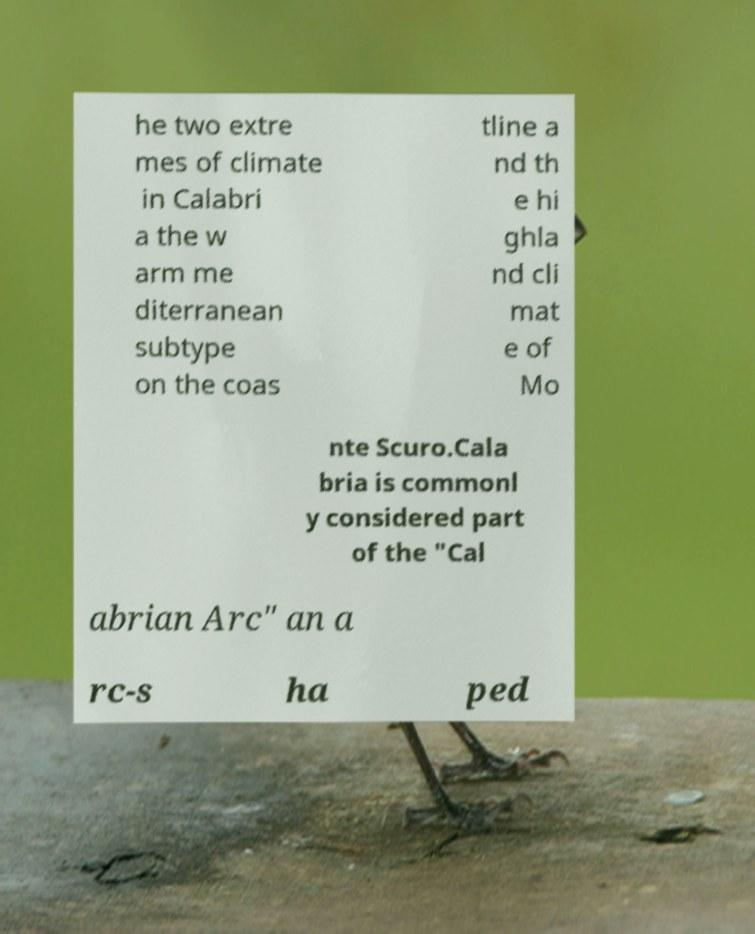Please identify and transcribe the text found in this image. he two extre mes of climate in Calabri a the w arm me diterranean subtype on the coas tline a nd th e hi ghla nd cli mat e of Mo nte Scuro.Cala bria is commonl y considered part of the "Cal abrian Arc" an a rc-s ha ped 